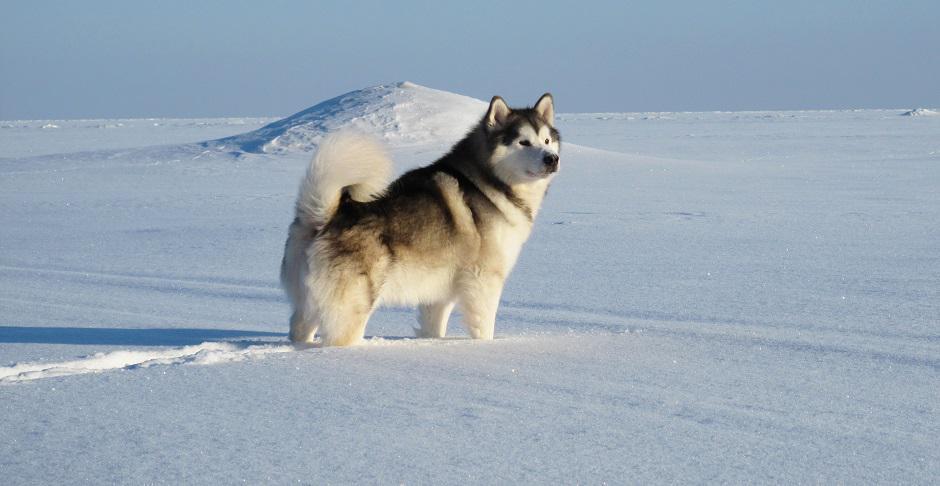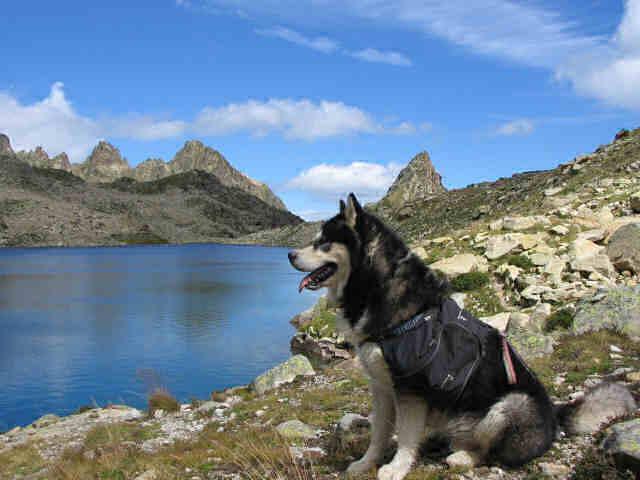The first image is the image on the left, the second image is the image on the right. Analyze the images presented: Is the assertion "Each image shows a line of at least four dogs heading in one direction, and at least one image shows dogs on a surface that is not covered in snow." valid? Answer yes or no. No. The first image is the image on the left, the second image is the image on the right. Evaluate the accuracy of this statement regarding the images: "There is a single dog in the snow in one image.". Is it true? Answer yes or no. Yes. 